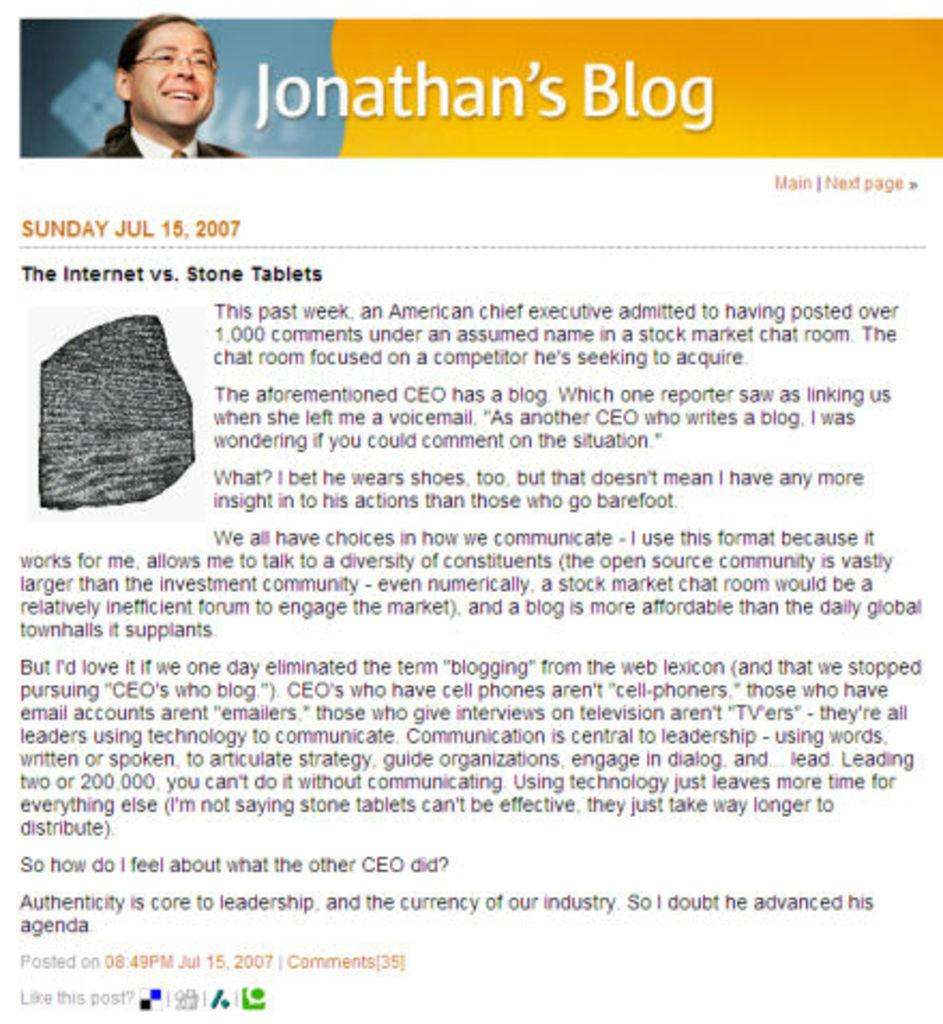What is the main subject of the screenshot? The main subject of the screenshot is a person's image. What other objects or elements can be seen in the screenshot? There is a rock and text visible in the screenshot. How many slaves are depicted in the image? There are no slaves present in the image; it features a person's image, a rock, and text. What type of horn can be seen in the image? There is no horn present in the image. 